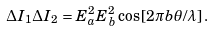<formula> <loc_0><loc_0><loc_500><loc_500>\Delta I _ { 1 } \Delta I _ { 2 } = E _ { a } ^ { 2 } E _ { b } ^ { 2 } \cos \left [ 2 \pi b \theta / \lambda \right ] .</formula> 